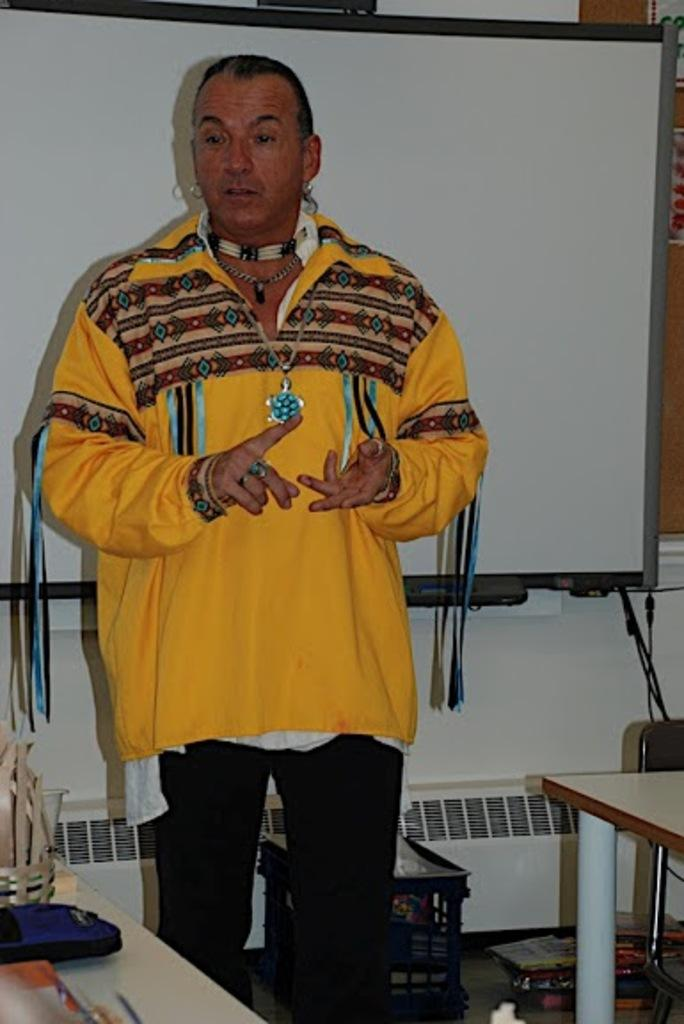Who is present in the image? There is a man in the image. What is the man wearing? The man is wearing a yellow shirt. What is the man doing in the image? The man is talking. What type of furniture can be seen in the image? There are tables in the image. What is on the tables in the image? There are items on the table. What can be seen in the background of the image? There is a board visible in the background of the image. What type of suit is the person wearing in the image? There is no person wearing a suit in the image; the man is wearing a yellow shirt. What brand of toothpaste is on the table in the image? There is no toothpaste present in the image. 